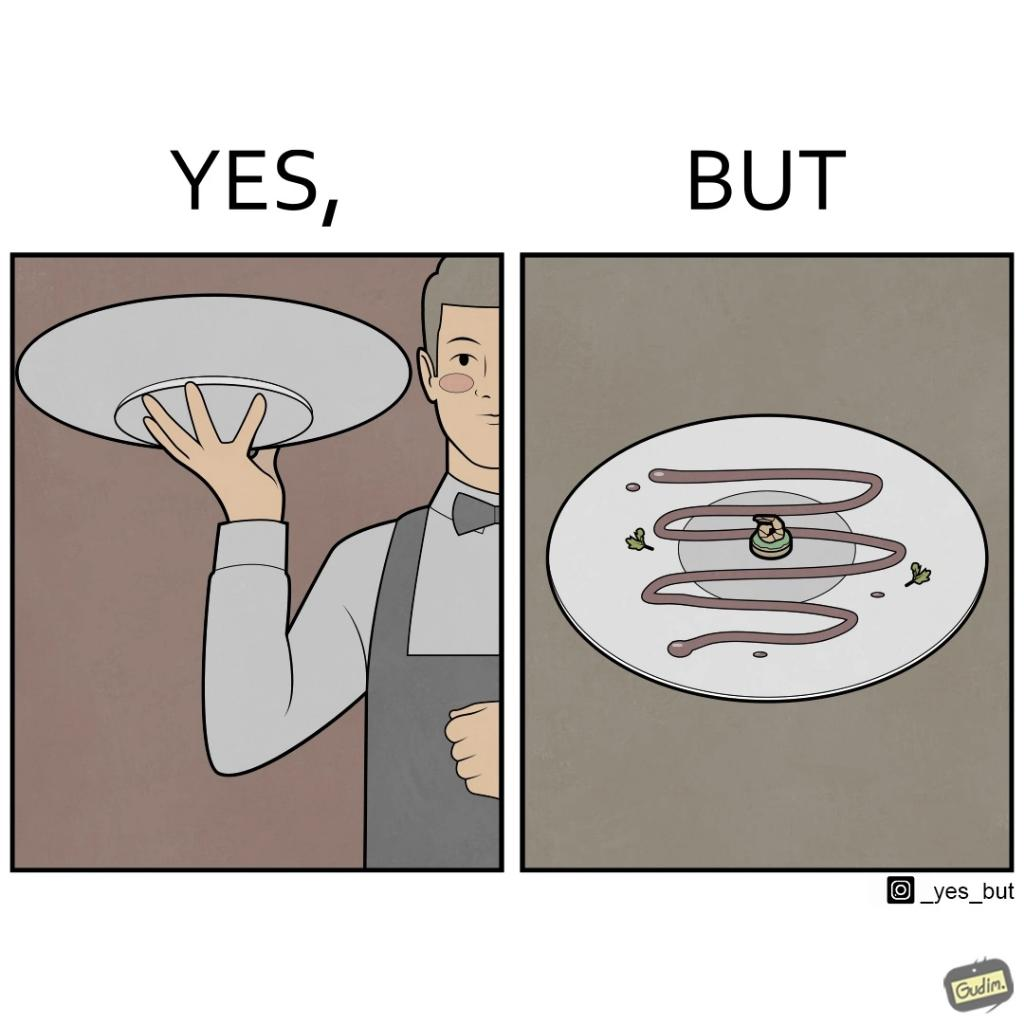Describe the content of this image. The image is ironic, because  in the first image the waiter is bringing the dish to the table presenting it as some lavish dish but in the second image when the dish is shown in the plate its just a small piece to eat 